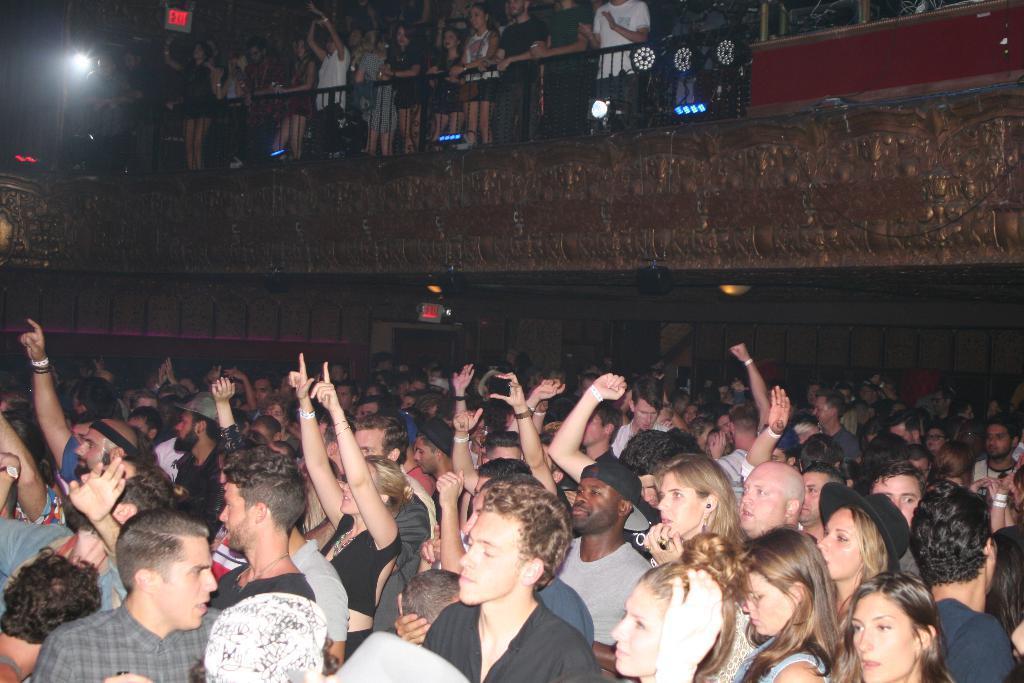Describe this image in one or two sentences. In this image there are group of people dancing, a few of them are holding phones and few of them are standing behind the balcony and cheering, we can also see few lights and exit boards around. 